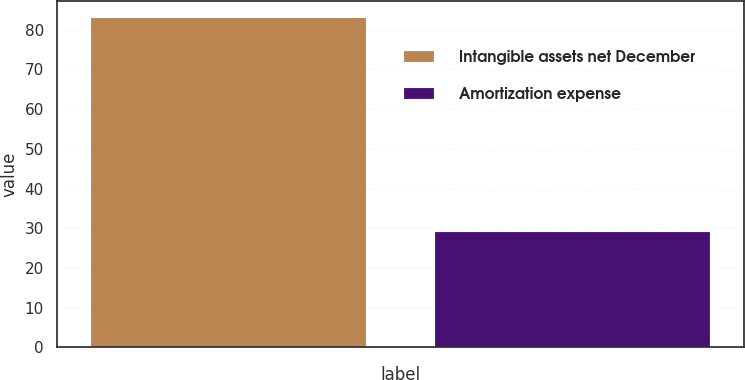Convert chart. <chart><loc_0><loc_0><loc_500><loc_500><bar_chart><fcel>Intangible assets net December<fcel>Amortization expense<nl><fcel>83<fcel>29<nl></chart> 